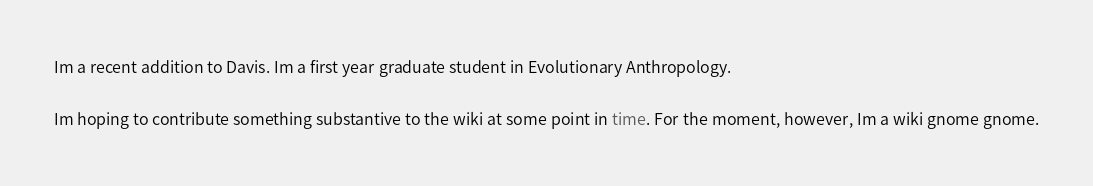<code> <loc_0><loc_0><loc_500><loc_500><_FORTRAN_>Im a recent addition to Davis. Im a first year graduate student in Evolutionary Anthropology.

Im hoping to contribute something substantive to the wiki at some point in time. For the moment, however, Im a wiki gnome gnome.
</code> 